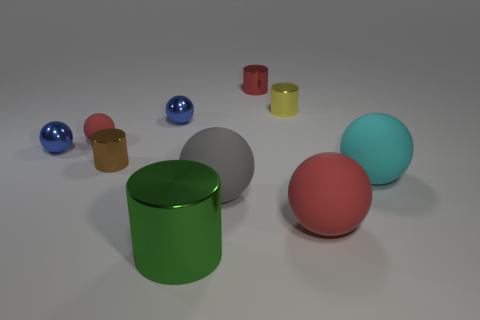Subtract all large gray balls. How many balls are left? 5 Subtract all brown cylinders. How many cylinders are left? 3 Subtract all cylinders. How many objects are left? 6 Subtract 2 cylinders. How many cylinders are left? 2 Add 4 large purple shiny cylinders. How many large purple shiny cylinders exist? 4 Subtract 1 green cylinders. How many objects are left? 9 Subtract all yellow balls. Subtract all red blocks. How many balls are left? 6 Subtract all gray cubes. How many purple cylinders are left? 0 Subtract all matte objects. Subtract all small red objects. How many objects are left? 4 Add 2 red spheres. How many red spheres are left? 4 